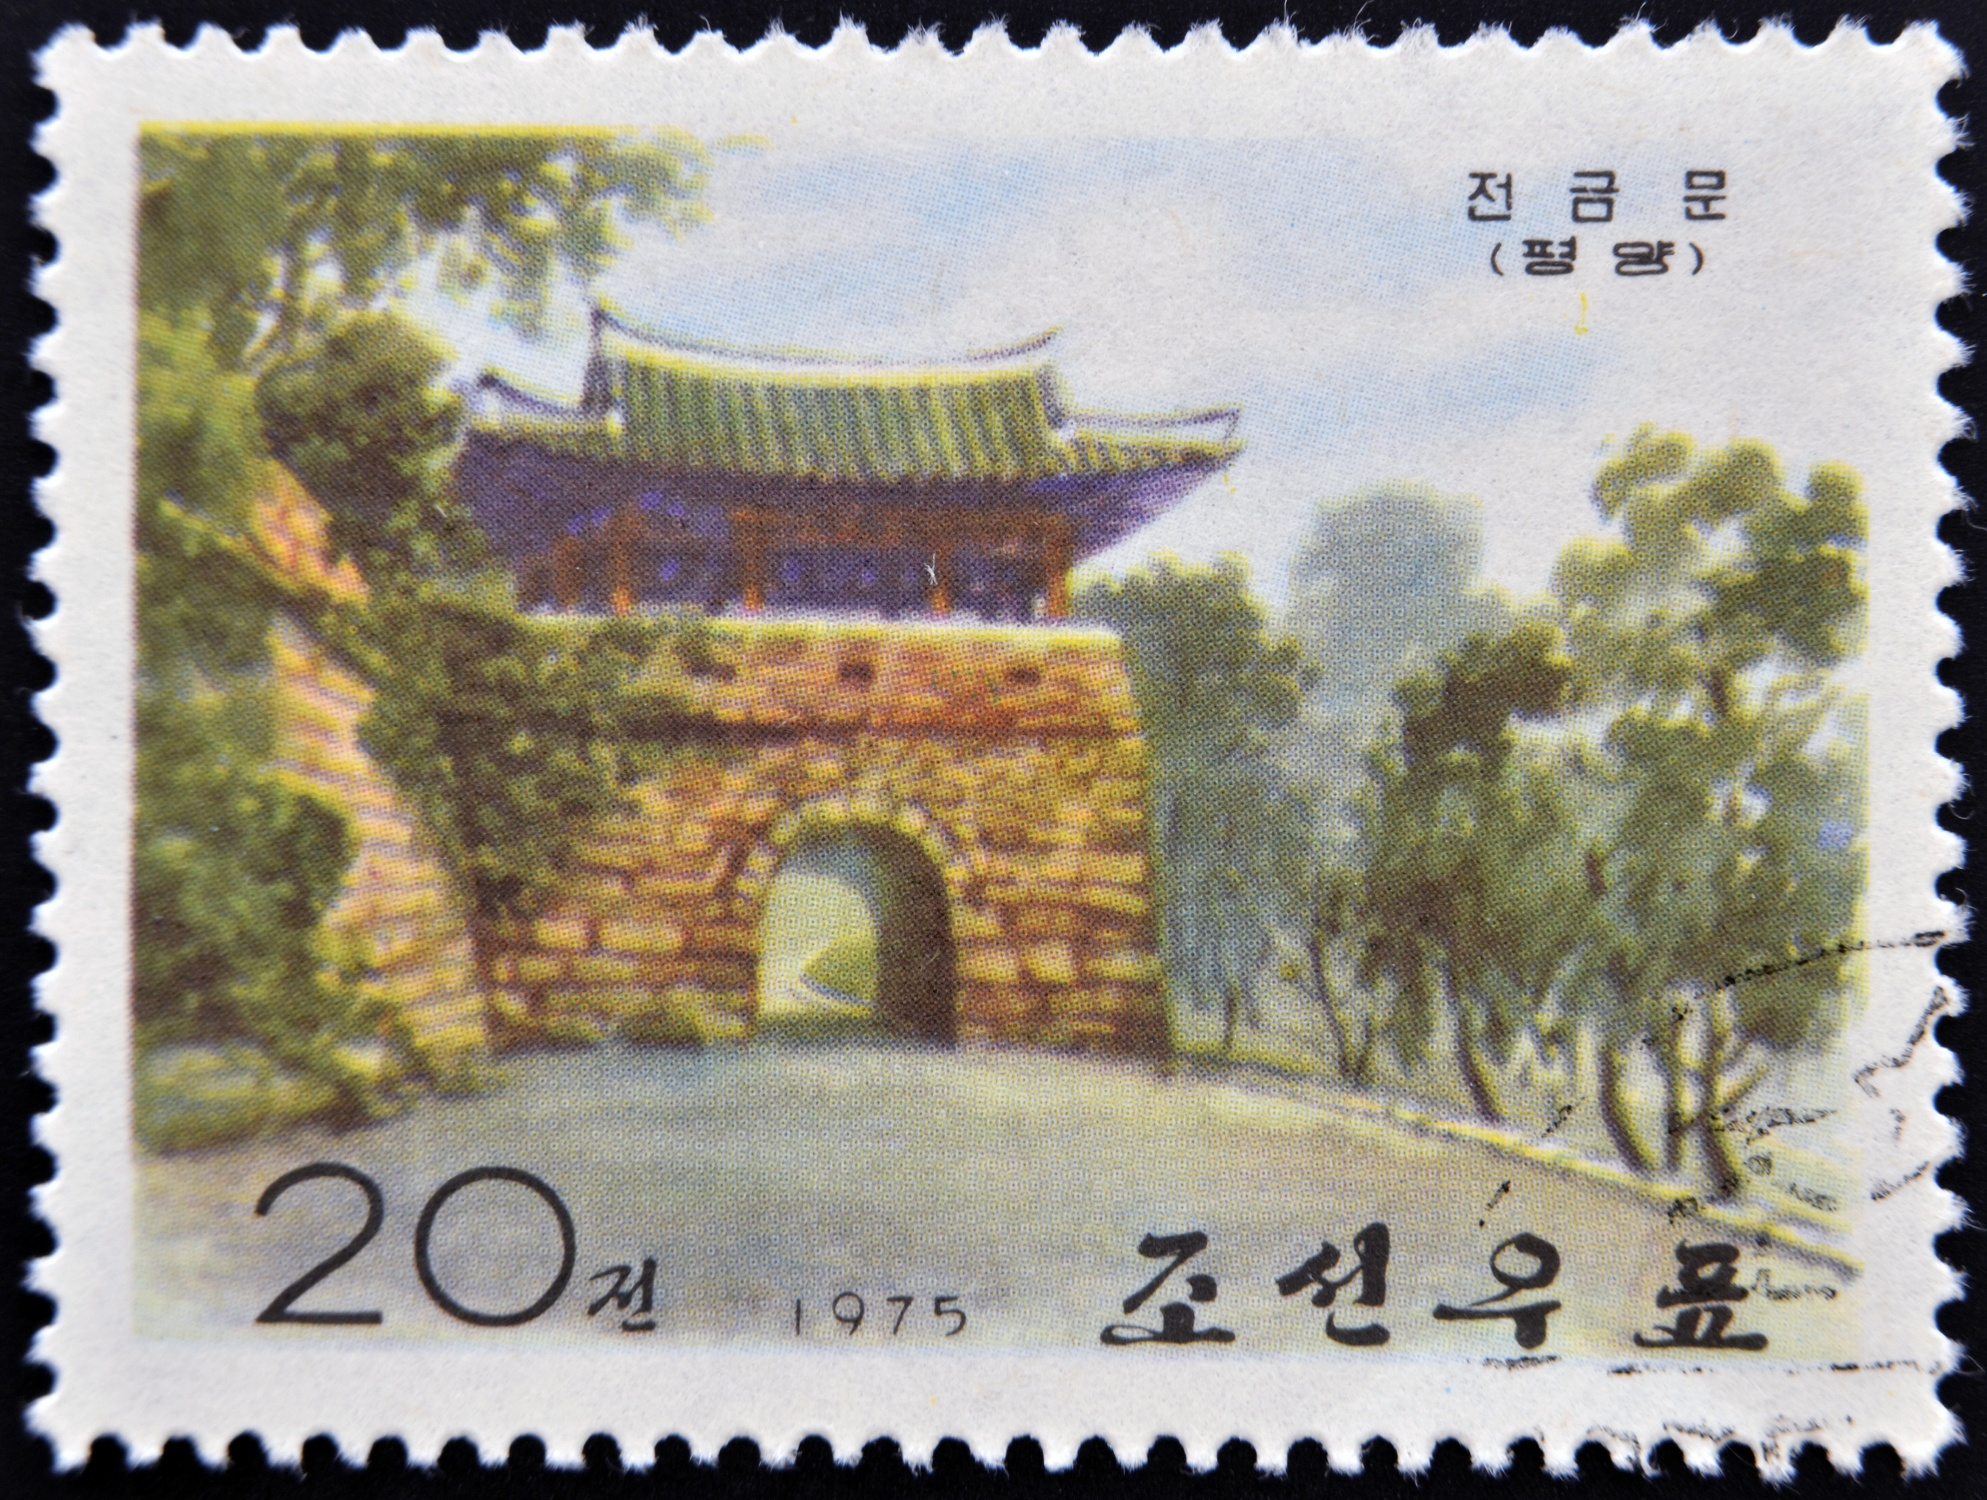Write a detailed description of the given image. The image is a stamp depicting a traditional Korean gate from 1975, as denoted by the text and date on the stamp. The structure of the gate is made of brick and features a distinct green roof with upturned eaves, which is a hallmark of Korean architectural design. The gate is set in a lush garden, enveloped by various trees and bushes that create a peaceful and serene ambiance. The perspective of the image captures the gate from the side and slightly below, accentuating its grandeur and majestic presence. The color scheme of the image primarily consists of green and brown hues, complemented by a touch of blue in the sky, which together enhance the harmonious blend of nature and architecture. Additionally, there is text on the stamp, '20전 1975 조선우표' translating to '20 won 1975 Democratic People's Republic of Korea', providing context about the stamp's origin and era. 